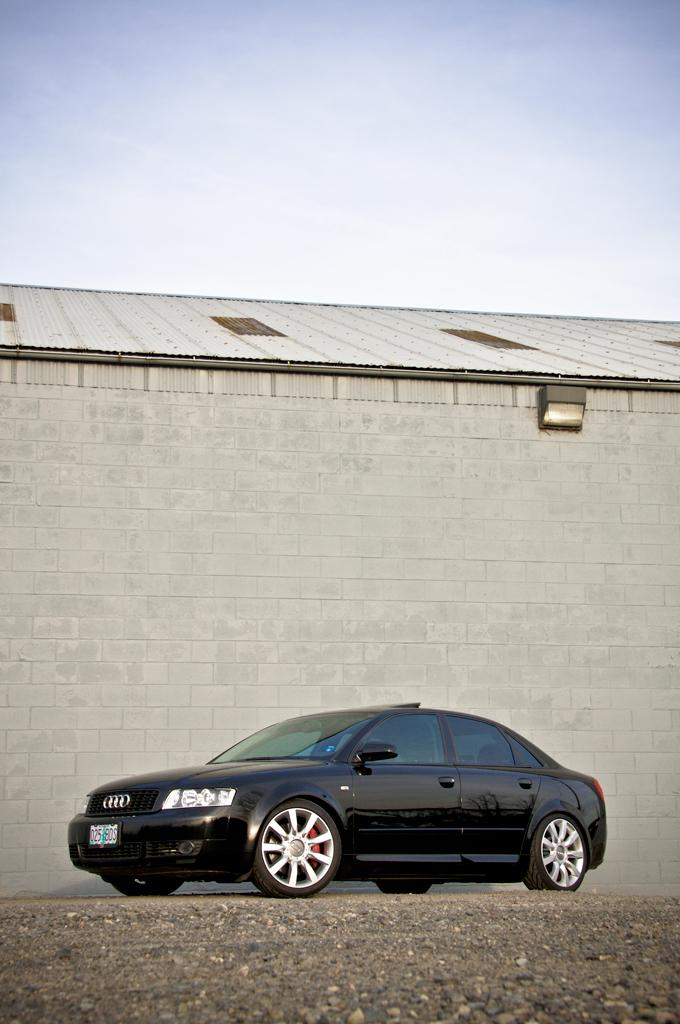What type of vehicle is in the image? There is a black car in the image. Where is the car located? The car is on the road. What can be seen in the background of the image? There is a wall in the background of the image. What is visible at the top of the image? The sky is visible at the top of the image. Is there a hammer visible in the image? No, there is no hammer present in the image. Is the car driving through snow in the image? No, there is no snow visible in the image. 